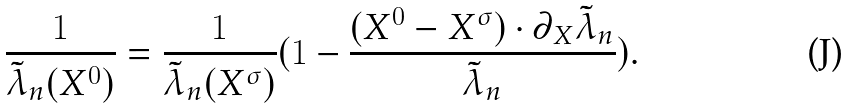<formula> <loc_0><loc_0><loc_500><loc_500>\frac { 1 } { \tilde { \lambda } _ { n } ( X ^ { 0 } ) } = \frac { 1 } { \tilde { \lambda } _ { n } ( X ^ { \sigma } ) } ( 1 - \frac { ( X ^ { 0 } - X ^ { \sigma } ) \cdot \partial _ { X } \tilde { \lambda } _ { n } } { \tilde { \lambda } _ { n } } ) .</formula> 